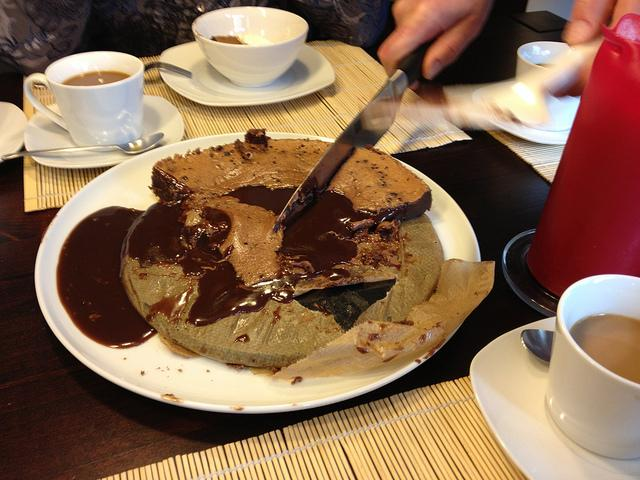What is being cut?

Choices:
A) chocolate sauce
B) pudding
C) gooey cake
D) bread gooey cake 